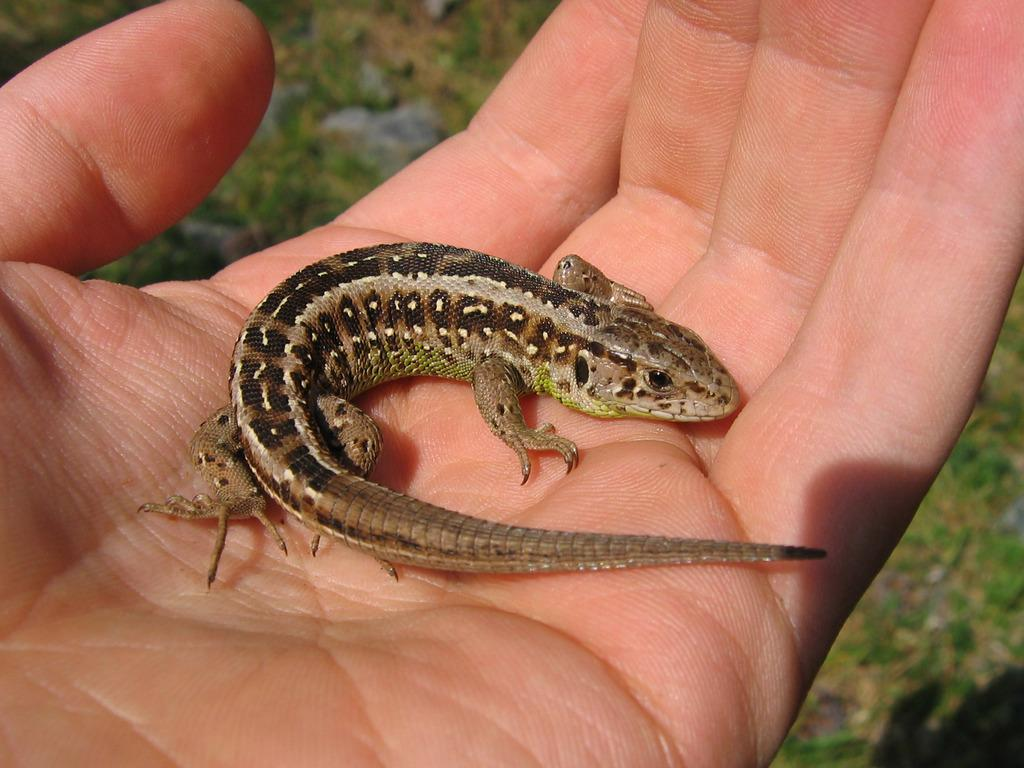What type of animal is in the image? There is a reptile in the image. What else can be seen in the image besides the reptile? There is a hand of a person in the image. Can you describe the background of the image? The background of the image is blurred. What type of lettuce is being used as a calendar in the image? There is no lettuce or calendar present in the image. 